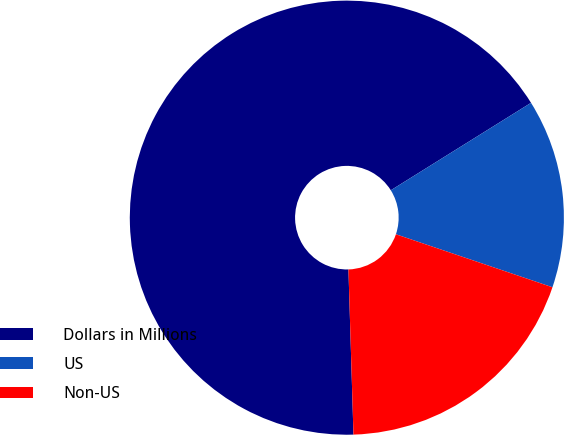Convert chart. <chart><loc_0><loc_0><loc_500><loc_500><pie_chart><fcel>Dollars in Millions<fcel>US<fcel>Non-US<nl><fcel>66.61%<fcel>14.07%<fcel>19.32%<nl></chart> 